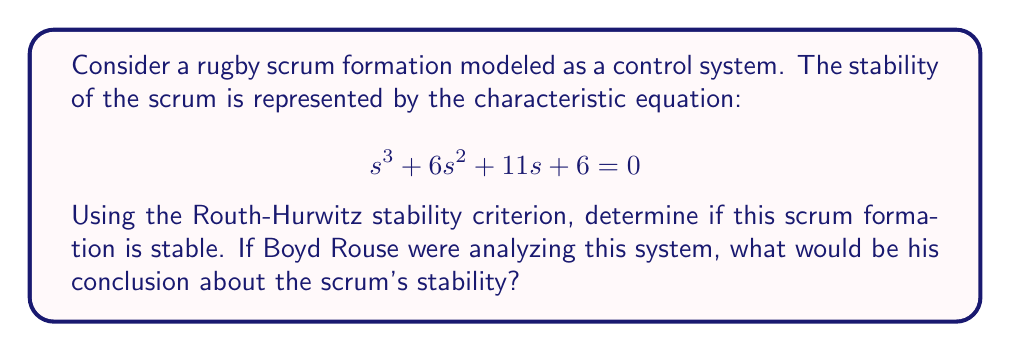Could you help me with this problem? To determine the stability of the scrum formation using the Routh-Hurwitz stability criterion, we follow these steps:

1. Write out the Routh array:

   $$\begin{array}{c|c}
   s^3 & 1 & 11 \\
   s^2 & 6 & 6 \\
   s^1 & a & 0 \\
   s^0 & b & 0
   \end{array}$$

2. Calculate the values of $a$ and $b$:

   $a = \frac{6 \cdot 11 - 1 \cdot 6}{6} = 10$

   $b = \frac{10 \cdot 6 - 0}{10} = 6$

3. Complete the Routh array:

   $$\begin{array}{c|c}
   s^3 & 1 & 11 \\
   s^2 & 6 & 6 \\
   s^1 & 10 & 0 \\
   s^0 & 6 & 0
   \end{array}$$

4. Analyze the first column of the Routh array:
   - All coefficients in the first column are positive (1, 6, 10, 6).
   - There are no sign changes in the first column.

5. Apply the Routh-Hurwitz stability criterion:
   - A system is stable if and only if all elements in the first column of the Routh array have the same sign (all positive or all negative).

In this case, all elements in the first column are positive, indicating that the system (scrum formation) is stable.

Boyd Rouse, known for his analytical approach to rugby, would likely appreciate this mathematical analysis of scrum stability. He would conclude that this scrum formation is indeed stable, as all the roots of the characteristic equation have negative real parts, ensuring that any small perturbations in the scrum will naturally dampen over time.
Answer: The scrum formation is stable. Boyd Rouse's conclusion would be that the scrum formation is stable based on the Routh-Hurwitz stability criterion, as all elements in the first column of the Routh array are positive. 